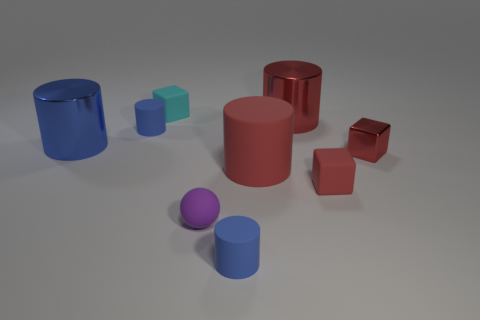How many blue cylinders must be subtracted to get 1 blue cylinders? 2 Subtract all yellow blocks. How many blue cylinders are left? 3 Add 1 big red matte things. How many objects exist? 10 Subtract all red cylinders. How many cylinders are left? 3 Subtract 1 cylinders. How many cylinders are left? 4 Subtract all large blue cylinders. How many cylinders are left? 4 Subtract all gray cylinders. Subtract all green spheres. How many cylinders are left? 5 Subtract all cylinders. How many objects are left? 4 Add 4 large cylinders. How many large cylinders exist? 7 Subtract 0 cyan balls. How many objects are left? 9 